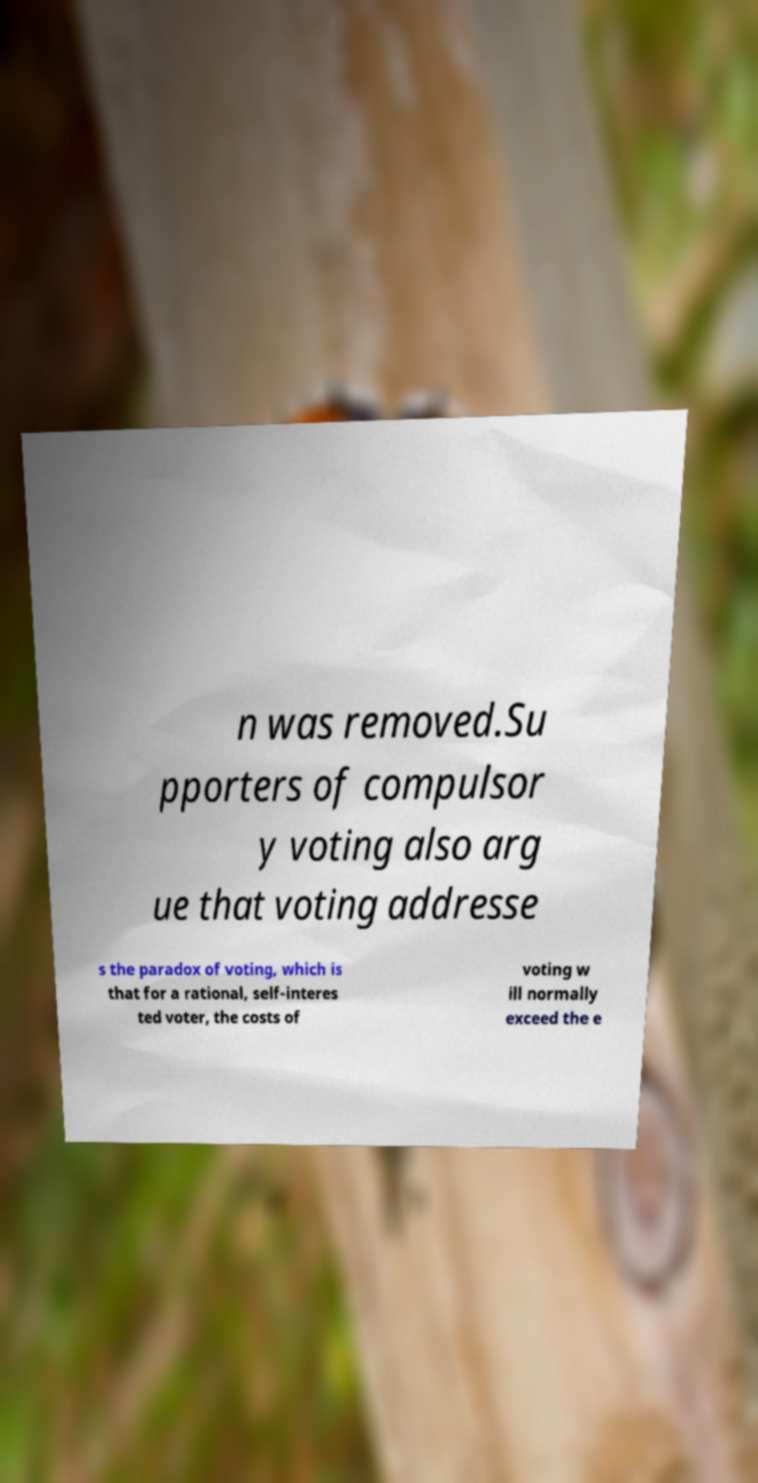There's text embedded in this image that I need extracted. Can you transcribe it verbatim? n was removed.Su pporters of compulsor y voting also arg ue that voting addresse s the paradox of voting, which is that for a rational, self-interes ted voter, the costs of voting w ill normally exceed the e 